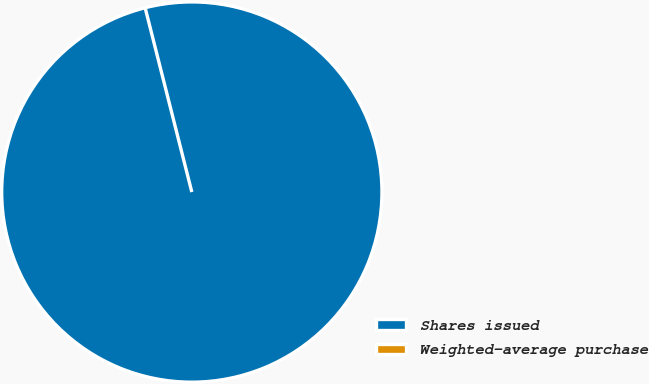Convert chart. <chart><loc_0><loc_0><loc_500><loc_500><pie_chart><fcel>Shares issued<fcel>Weighted-average purchase<nl><fcel>100.0%<fcel>0.0%<nl></chart> 